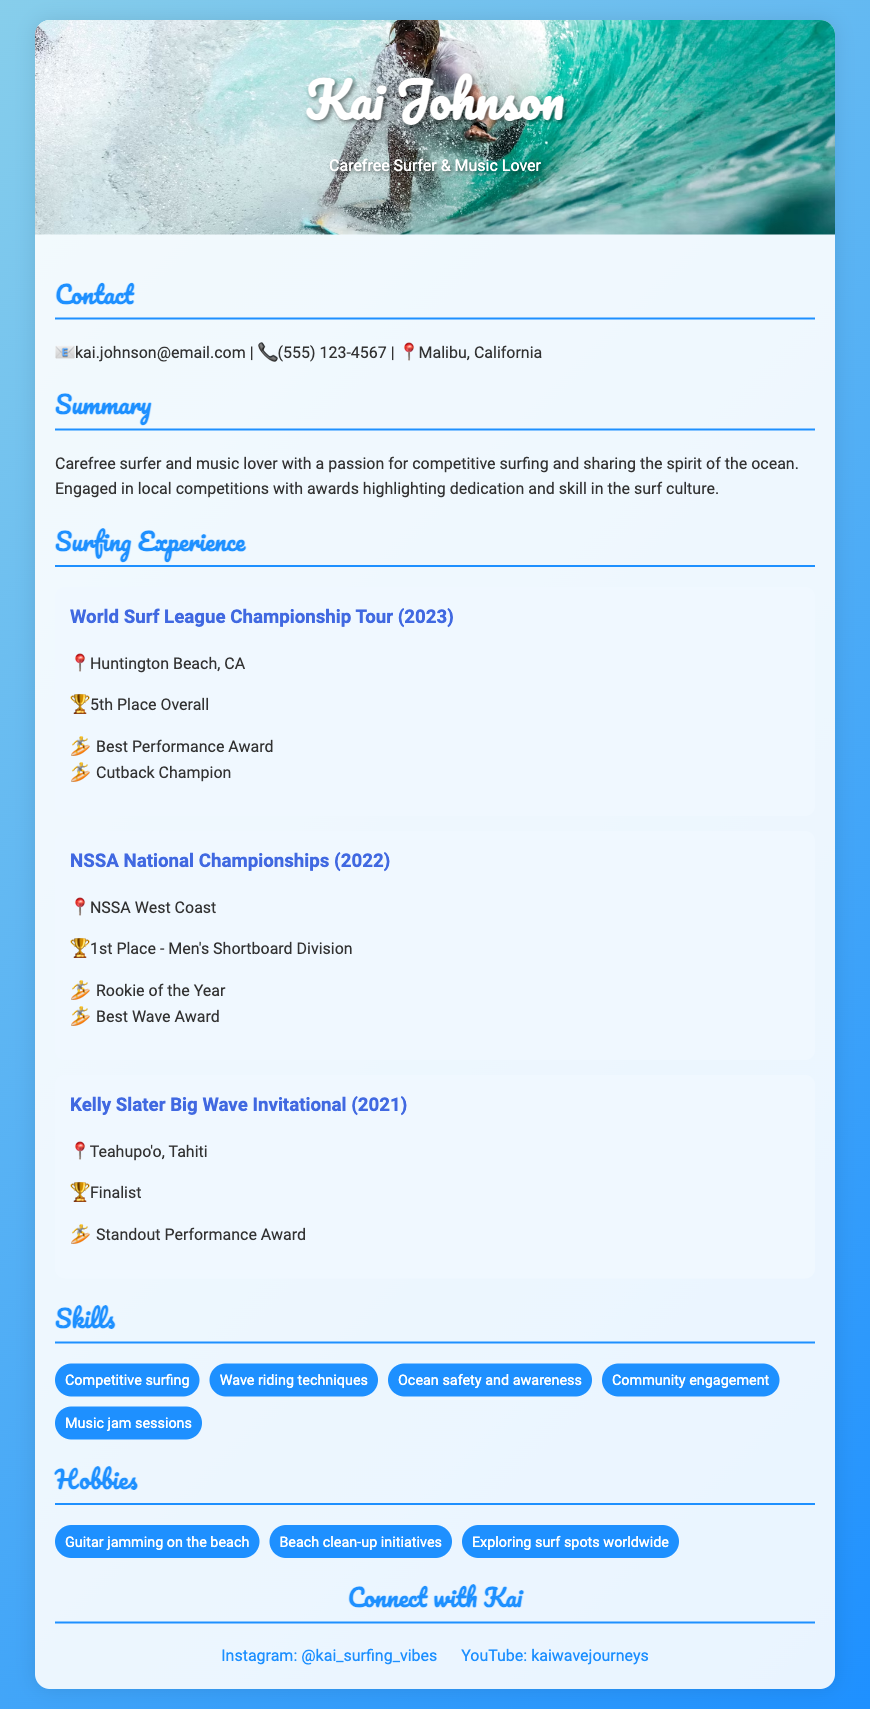What is Kai Johnson's email address? The email address listed in the document is provided directly under the contact section.
Answer: kai.johnson@email.com What place did Kai Johnson achieve in the World Surf League Championship Tour? The document states the overall rank achieved during the competition as noted in the surfing experience section.
Answer: 5th Place Overall Which award did Kai receive at the NSSA National Championships? The document mentions awards listed under the NSSA National Championships experience entry, which clarifies the recognition received.
Answer: Rookie of the Year What was the location of the Kelly Slater Big Wave Invitational? The location for the competition is specified next to the event title in the surfing experience section.
Answer: Teahupo'o, Tahiti How many competitions are highlighted in the surfing experience section? Counting the experience entries provides an understanding of Kai's participation.
Answer: 3 Which skill related to music is mentioned in the Skills section? The document lists various skills, including those that relate to music, which are part of Kai's profile.
Answer: Music jam sessions What year did Kai win 1st Place in the Men's Shortboard Division? The year is specified next to the competition result under the NSSA National Championships experience.
Answer: 2022 What type of initiatives does Kai engage in as a hobby? The hobbies section highlights particular activities that reflect Kai's community involvement.
Answer: Beach clean-up initiatives What is Kai's social media handle on Instagram? The Instagram handle is provided in the connect section and is specific to Kai's surfing content.
Answer: @kai_surfing_vibes 